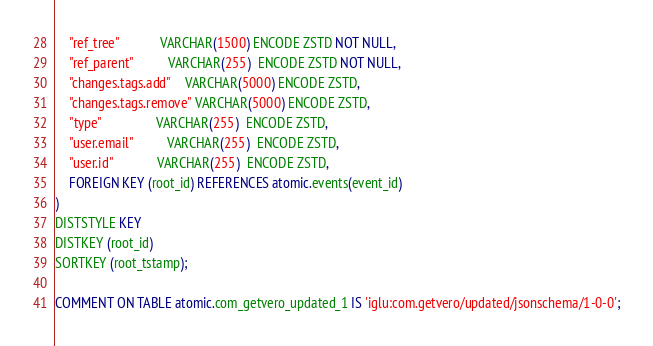Convert code to text. <code><loc_0><loc_0><loc_500><loc_500><_SQL_>    "ref_tree"            VARCHAR(1500) ENCODE ZSTD NOT NULL,
    "ref_parent"          VARCHAR(255)  ENCODE ZSTD NOT NULL,
    "changes.tags.add"    VARCHAR(5000) ENCODE ZSTD,
    "changes.tags.remove" VARCHAR(5000) ENCODE ZSTD,
    "type"                VARCHAR(255)  ENCODE ZSTD,
    "user.email"          VARCHAR(255)  ENCODE ZSTD,
    "user.id"             VARCHAR(255)  ENCODE ZSTD,
    FOREIGN KEY (root_id) REFERENCES atomic.events(event_id)
)
DISTSTYLE KEY
DISTKEY (root_id)
SORTKEY (root_tstamp);

COMMENT ON TABLE atomic.com_getvero_updated_1 IS 'iglu:com.getvero/updated/jsonschema/1-0-0';
</code> 